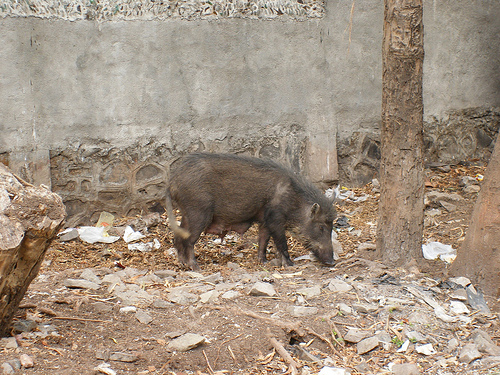<image>
Is there a dog on the grass? Yes. Looking at the image, I can see the dog is positioned on top of the grass, with the grass providing support. Is there a boar on the wall? No. The boar is not positioned on the wall. They may be near each other, but the boar is not supported by or resting on top of the wall. 